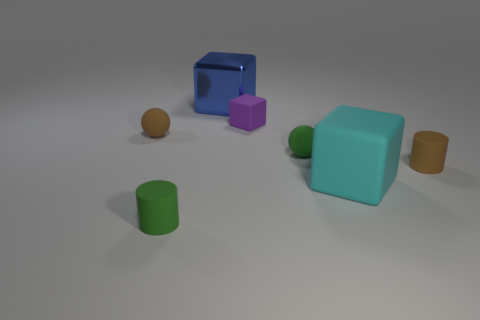Subtract all yellow balls. Subtract all yellow cylinders. How many balls are left? 2 Add 3 metal blocks. How many objects exist? 10 Subtract all spheres. How many objects are left? 5 Subtract all green matte balls. Subtract all tiny yellow metal cylinders. How many objects are left? 6 Add 3 brown matte balls. How many brown matte balls are left? 4 Add 6 small gray rubber cylinders. How many small gray rubber cylinders exist? 6 Subtract 1 cyan cubes. How many objects are left? 6 